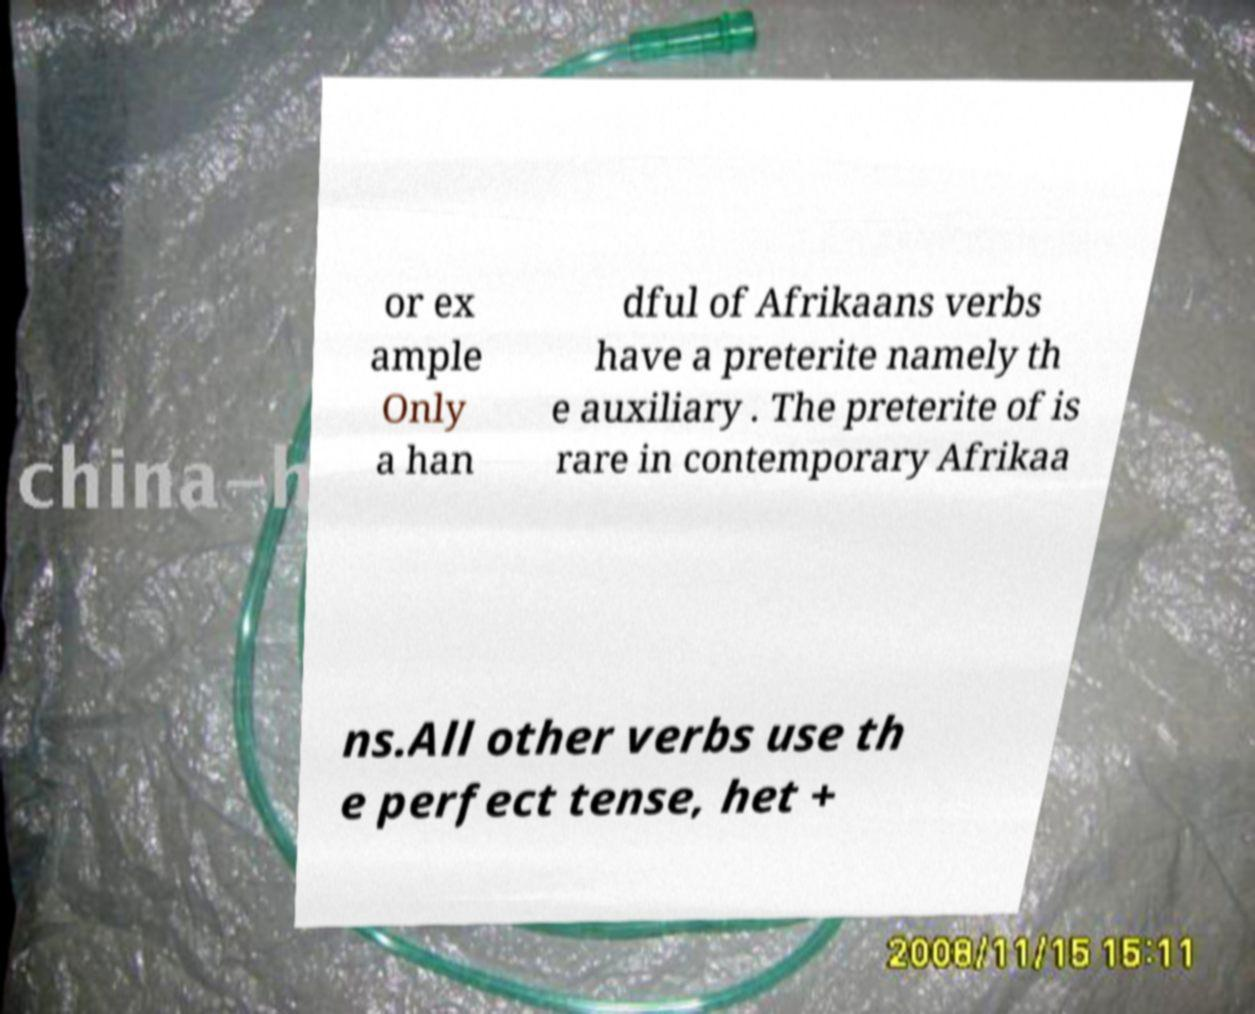Can you accurately transcribe the text from the provided image for me? or ex ample Only a han dful of Afrikaans verbs have a preterite namely th e auxiliary . The preterite of is rare in contemporary Afrikaa ns.All other verbs use th e perfect tense, het + 